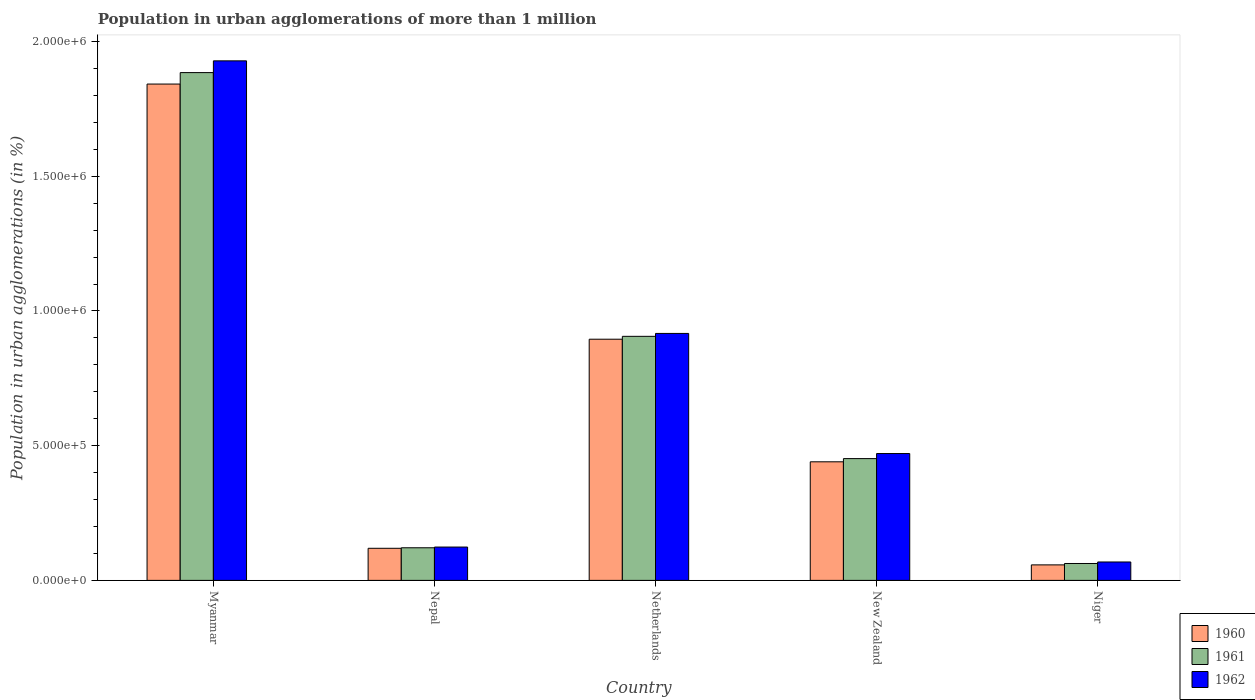How many different coloured bars are there?
Provide a short and direct response. 3. How many groups of bars are there?
Your response must be concise. 5. Are the number of bars on each tick of the X-axis equal?
Offer a terse response. Yes. How many bars are there on the 5th tick from the left?
Ensure brevity in your answer.  3. What is the label of the 1st group of bars from the left?
Provide a succinct answer. Myanmar. In how many cases, is the number of bars for a given country not equal to the number of legend labels?
Provide a short and direct response. 0. What is the population in urban agglomerations in 1960 in Niger?
Give a very brief answer. 5.75e+04. Across all countries, what is the maximum population in urban agglomerations in 1962?
Provide a succinct answer. 1.93e+06. Across all countries, what is the minimum population in urban agglomerations in 1962?
Ensure brevity in your answer.  6.83e+04. In which country was the population in urban agglomerations in 1960 maximum?
Make the answer very short. Myanmar. In which country was the population in urban agglomerations in 1960 minimum?
Offer a terse response. Niger. What is the total population in urban agglomerations in 1962 in the graph?
Offer a terse response. 3.51e+06. What is the difference between the population in urban agglomerations in 1961 in Netherlands and that in New Zealand?
Give a very brief answer. 4.54e+05. What is the difference between the population in urban agglomerations in 1961 in Myanmar and the population in urban agglomerations in 1962 in Niger?
Offer a terse response. 1.82e+06. What is the average population in urban agglomerations in 1960 per country?
Your response must be concise. 6.71e+05. What is the difference between the population in urban agglomerations of/in 1962 and population in urban agglomerations of/in 1960 in Nepal?
Provide a succinct answer. 4568. In how many countries, is the population in urban agglomerations in 1961 greater than 1900000 %?
Provide a succinct answer. 0. What is the ratio of the population in urban agglomerations in 1960 in Myanmar to that in Netherlands?
Make the answer very short. 2.06. Is the population in urban agglomerations in 1960 in Myanmar less than that in Netherlands?
Your answer should be compact. No. What is the difference between the highest and the second highest population in urban agglomerations in 1962?
Offer a very short reply. -1.01e+06. What is the difference between the highest and the lowest population in urban agglomerations in 1960?
Give a very brief answer. 1.78e+06. What does the 3rd bar from the left in Netherlands represents?
Offer a very short reply. 1962. What does the 1st bar from the right in Niger represents?
Make the answer very short. 1962. How many bars are there?
Provide a short and direct response. 15. Are all the bars in the graph horizontal?
Keep it short and to the point. No. How many countries are there in the graph?
Ensure brevity in your answer.  5. What is the difference between two consecutive major ticks on the Y-axis?
Give a very brief answer. 5.00e+05. Are the values on the major ticks of Y-axis written in scientific E-notation?
Ensure brevity in your answer.  Yes. Does the graph contain any zero values?
Keep it short and to the point. No. Does the graph contain grids?
Give a very brief answer. No. How are the legend labels stacked?
Your answer should be very brief. Vertical. What is the title of the graph?
Provide a short and direct response. Population in urban agglomerations of more than 1 million. Does "1969" appear as one of the legend labels in the graph?
Offer a very short reply. No. What is the label or title of the X-axis?
Give a very brief answer. Country. What is the label or title of the Y-axis?
Offer a terse response. Population in urban agglomerations (in %). What is the Population in urban agglomerations (in %) of 1960 in Myanmar?
Your response must be concise. 1.84e+06. What is the Population in urban agglomerations (in %) of 1961 in Myanmar?
Provide a succinct answer. 1.88e+06. What is the Population in urban agglomerations (in %) of 1962 in Myanmar?
Make the answer very short. 1.93e+06. What is the Population in urban agglomerations (in %) in 1960 in Nepal?
Your answer should be compact. 1.19e+05. What is the Population in urban agglomerations (in %) in 1961 in Nepal?
Keep it short and to the point. 1.21e+05. What is the Population in urban agglomerations (in %) in 1962 in Nepal?
Offer a very short reply. 1.24e+05. What is the Population in urban agglomerations (in %) of 1960 in Netherlands?
Ensure brevity in your answer.  8.95e+05. What is the Population in urban agglomerations (in %) of 1961 in Netherlands?
Your answer should be very brief. 9.06e+05. What is the Population in urban agglomerations (in %) of 1962 in Netherlands?
Ensure brevity in your answer.  9.17e+05. What is the Population in urban agglomerations (in %) in 1960 in New Zealand?
Your response must be concise. 4.40e+05. What is the Population in urban agglomerations (in %) of 1961 in New Zealand?
Your answer should be very brief. 4.52e+05. What is the Population in urban agglomerations (in %) in 1962 in New Zealand?
Keep it short and to the point. 4.71e+05. What is the Population in urban agglomerations (in %) of 1960 in Niger?
Your answer should be compact. 5.75e+04. What is the Population in urban agglomerations (in %) of 1961 in Niger?
Your answer should be compact. 6.27e+04. What is the Population in urban agglomerations (in %) in 1962 in Niger?
Keep it short and to the point. 6.83e+04. Across all countries, what is the maximum Population in urban agglomerations (in %) of 1960?
Your answer should be very brief. 1.84e+06. Across all countries, what is the maximum Population in urban agglomerations (in %) in 1961?
Make the answer very short. 1.88e+06. Across all countries, what is the maximum Population in urban agglomerations (in %) in 1962?
Make the answer very short. 1.93e+06. Across all countries, what is the minimum Population in urban agglomerations (in %) of 1960?
Your answer should be compact. 5.75e+04. Across all countries, what is the minimum Population in urban agglomerations (in %) of 1961?
Your answer should be very brief. 6.27e+04. Across all countries, what is the minimum Population in urban agglomerations (in %) in 1962?
Offer a very short reply. 6.83e+04. What is the total Population in urban agglomerations (in %) of 1960 in the graph?
Offer a terse response. 3.35e+06. What is the total Population in urban agglomerations (in %) in 1961 in the graph?
Ensure brevity in your answer.  3.43e+06. What is the total Population in urban agglomerations (in %) of 1962 in the graph?
Your answer should be compact. 3.51e+06. What is the difference between the Population in urban agglomerations (in %) of 1960 in Myanmar and that in Nepal?
Keep it short and to the point. 1.72e+06. What is the difference between the Population in urban agglomerations (in %) of 1961 in Myanmar and that in Nepal?
Ensure brevity in your answer.  1.76e+06. What is the difference between the Population in urban agglomerations (in %) in 1962 in Myanmar and that in Nepal?
Ensure brevity in your answer.  1.80e+06. What is the difference between the Population in urban agglomerations (in %) in 1960 in Myanmar and that in Netherlands?
Provide a succinct answer. 9.47e+05. What is the difference between the Population in urban agglomerations (in %) in 1961 in Myanmar and that in Netherlands?
Keep it short and to the point. 9.79e+05. What is the difference between the Population in urban agglomerations (in %) of 1962 in Myanmar and that in Netherlands?
Ensure brevity in your answer.  1.01e+06. What is the difference between the Population in urban agglomerations (in %) of 1960 in Myanmar and that in New Zealand?
Provide a short and direct response. 1.40e+06. What is the difference between the Population in urban agglomerations (in %) of 1961 in Myanmar and that in New Zealand?
Offer a terse response. 1.43e+06. What is the difference between the Population in urban agglomerations (in %) in 1962 in Myanmar and that in New Zealand?
Offer a very short reply. 1.46e+06. What is the difference between the Population in urban agglomerations (in %) in 1960 in Myanmar and that in Niger?
Provide a succinct answer. 1.78e+06. What is the difference between the Population in urban agglomerations (in %) of 1961 in Myanmar and that in Niger?
Make the answer very short. 1.82e+06. What is the difference between the Population in urban agglomerations (in %) of 1962 in Myanmar and that in Niger?
Your response must be concise. 1.86e+06. What is the difference between the Population in urban agglomerations (in %) of 1960 in Nepal and that in Netherlands?
Make the answer very short. -7.76e+05. What is the difference between the Population in urban agglomerations (in %) of 1961 in Nepal and that in Netherlands?
Your response must be concise. -7.85e+05. What is the difference between the Population in urban agglomerations (in %) in 1962 in Nepal and that in Netherlands?
Keep it short and to the point. -7.93e+05. What is the difference between the Population in urban agglomerations (in %) of 1960 in Nepal and that in New Zealand?
Keep it short and to the point. -3.21e+05. What is the difference between the Population in urban agglomerations (in %) in 1961 in Nepal and that in New Zealand?
Offer a very short reply. -3.31e+05. What is the difference between the Population in urban agglomerations (in %) of 1962 in Nepal and that in New Zealand?
Your answer should be compact. -3.47e+05. What is the difference between the Population in urban agglomerations (in %) of 1960 in Nepal and that in Niger?
Your response must be concise. 6.16e+04. What is the difference between the Population in urban agglomerations (in %) of 1961 in Nepal and that in Niger?
Provide a short and direct response. 5.84e+04. What is the difference between the Population in urban agglomerations (in %) of 1962 in Nepal and that in Niger?
Offer a very short reply. 5.54e+04. What is the difference between the Population in urban agglomerations (in %) of 1960 in Netherlands and that in New Zealand?
Your response must be concise. 4.55e+05. What is the difference between the Population in urban agglomerations (in %) in 1961 in Netherlands and that in New Zealand?
Keep it short and to the point. 4.54e+05. What is the difference between the Population in urban agglomerations (in %) of 1962 in Netherlands and that in New Zealand?
Your answer should be very brief. 4.46e+05. What is the difference between the Population in urban agglomerations (in %) in 1960 in Netherlands and that in Niger?
Provide a succinct answer. 8.38e+05. What is the difference between the Population in urban agglomerations (in %) in 1961 in Netherlands and that in Niger?
Offer a terse response. 8.43e+05. What is the difference between the Population in urban agglomerations (in %) in 1962 in Netherlands and that in Niger?
Provide a short and direct response. 8.48e+05. What is the difference between the Population in urban agglomerations (in %) of 1960 in New Zealand and that in Niger?
Provide a succinct answer. 3.83e+05. What is the difference between the Population in urban agglomerations (in %) in 1961 in New Zealand and that in Niger?
Your answer should be compact. 3.89e+05. What is the difference between the Population in urban agglomerations (in %) in 1962 in New Zealand and that in Niger?
Your answer should be very brief. 4.03e+05. What is the difference between the Population in urban agglomerations (in %) of 1960 in Myanmar and the Population in urban agglomerations (in %) of 1961 in Nepal?
Offer a very short reply. 1.72e+06. What is the difference between the Population in urban agglomerations (in %) of 1960 in Myanmar and the Population in urban agglomerations (in %) of 1962 in Nepal?
Make the answer very short. 1.72e+06. What is the difference between the Population in urban agglomerations (in %) of 1961 in Myanmar and the Population in urban agglomerations (in %) of 1962 in Nepal?
Ensure brevity in your answer.  1.76e+06. What is the difference between the Population in urban agglomerations (in %) of 1960 in Myanmar and the Population in urban agglomerations (in %) of 1961 in Netherlands?
Your answer should be compact. 9.36e+05. What is the difference between the Population in urban agglomerations (in %) of 1960 in Myanmar and the Population in urban agglomerations (in %) of 1962 in Netherlands?
Provide a succinct answer. 9.26e+05. What is the difference between the Population in urban agglomerations (in %) in 1961 in Myanmar and the Population in urban agglomerations (in %) in 1962 in Netherlands?
Give a very brief answer. 9.68e+05. What is the difference between the Population in urban agglomerations (in %) in 1960 in Myanmar and the Population in urban agglomerations (in %) in 1961 in New Zealand?
Ensure brevity in your answer.  1.39e+06. What is the difference between the Population in urban agglomerations (in %) in 1960 in Myanmar and the Population in urban agglomerations (in %) in 1962 in New Zealand?
Give a very brief answer. 1.37e+06. What is the difference between the Population in urban agglomerations (in %) of 1961 in Myanmar and the Population in urban agglomerations (in %) of 1962 in New Zealand?
Your answer should be compact. 1.41e+06. What is the difference between the Population in urban agglomerations (in %) in 1960 in Myanmar and the Population in urban agglomerations (in %) in 1961 in Niger?
Give a very brief answer. 1.78e+06. What is the difference between the Population in urban agglomerations (in %) in 1960 in Myanmar and the Population in urban agglomerations (in %) in 1962 in Niger?
Give a very brief answer. 1.77e+06. What is the difference between the Population in urban agglomerations (in %) in 1961 in Myanmar and the Population in urban agglomerations (in %) in 1962 in Niger?
Keep it short and to the point. 1.82e+06. What is the difference between the Population in urban agglomerations (in %) in 1960 in Nepal and the Population in urban agglomerations (in %) in 1961 in Netherlands?
Make the answer very short. -7.87e+05. What is the difference between the Population in urban agglomerations (in %) of 1960 in Nepal and the Population in urban agglomerations (in %) of 1962 in Netherlands?
Your answer should be very brief. -7.98e+05. What is the difference between the Population in urban agglomerations (in %) of 1961 in Nepal and the Population in urban agglomerations (in %) of 1962 in Netherlands?
Offer a very short reply. -7.96e+05. What is the difference between the Population in urban agglomerations (in %) in 1960 in Nepal and the Population in urban agglomerations (in %) in 1961 in New Zealand?
Your answer should be compact. -3.33e+05. What is the difference between the Population in urban agglomerations (in %) of 1960 in Nepal and the Population in urban agglomerations (in %) of 1962 in New Zealand?
Offer a very short reply. -3.52e+05. What is the difference between the Population in urban agglomerations (in %) of 1961 in Nepal and the Population in urban agglomerations (in %) of 1962 in New Zealand?
Offer a terse response. -3.50e+05. What is the difference between the Population in urban agglomerations (in %) in 1960 in Nepal and the Population in urban agglomerations (in %) in 1961 in Niger?
Keep it short and to the point. 5.65e+04. What is the difference between the Population in urban agglomerations (in %) in 1960 in Nepal and the Population in urban agglomerations (in %) in 1962 in Niger?
Your answer should be compact. 5.08e+04. What is the difference between the Population in urban agglomerations (in %) in 1961 in Nepal and the Population in urban agglomerations (in %) in 1962 in Niger?
Your answer should be compact. 5.28e+04. What is the difference between the Population in urban agglomerations (in %) in 1960 in Netherlands and the Population in urban agglomerations (in %) in 1961 in New Zealand?
Your answer should be compact. 4.43e+05. What is the difference between the Population in urban agglomerations (in %) of 1960 in Netherlands and the Population in urban agglomerations (in %) of 1962 in New Zealand?
Keep it short and to the point. 4.24e+05. What is the difference between the Population in urban agglomerations (in %) in 1961 in Netherlands and the Population in urban agglomerations (in %) in 1962 in New Zealand?
Ensure brevity in your answer.  4.35e+05. What is the difference between the Population in urban agglomerations (in %) of 1960 in Netherlands and the Population in urban agglomerations (in %) of 1961 in Niger?
Your answer should be compact. 8.33e+05. What is the difference between the Population in urban agglomerations (in %) of 1960 in Netherlands and the Population in urban agglomerations (in %) of 1962 in Niger?
Your response must be concise. 8.27e+05. What is the difference between the Population in urban agglomerations (in %) of 1961 in Netherlands and the Population in urban agglomerations (in %) of 1962 in Niger?
Provide a succinct answer. 8.38e+05. What is the difference between the Population in urban agglomerations (in %) in 1960 in New Zealand and the Population in urban agglomerations (in %) in 1961 in Niger?
Your response must be concise. 3.77e+05. What is the difference between the Population in urban agglomerations (in %) of 1960 in New Zealand and the Population in urban agglomerations (in %) of 1962 in Niger?
Your answer should be very brief. 3.72e+05. What is the difference between the Population in urban agglomerations (in %) in 1961 in New Zealand and the Population in urban agglomerations (in %) in 1962 in Niger?
Make the answer very short. 3.84e+05. What is the average Population in urban agglomerations (in %) of 1960 per country?
Offer a terse response. 6.71e+05. What is the average Population in urban agglomerations (in %) of 1961 per country?
Keep it short and to the point. 6.85e+05. What is the average Population in urban agglomerations (in %) in 1962 per country?
Ensure brevity in your answer.  7.02e+05. What is the difference between the Population in urban agglomerations (in %) in 1960 and Population in urban agglomerations (in %) in 1961 in Myanmar?
Your answer should be very brief. -4.25e+04. What is the difference between the Population in urban agglomerations (in %) of 1960 and Population in urban agglomerations (in %) of 1962 in Myanmar?
Offer a very short reply. -8.61e+04. What is the difference between the Population in urban agglomerations (in %) in 1961 and Population in urban agglomerations (in %) in 1962 in Myanmar?
Ensure brevity in your answer.  -4.36e+04. What is the difference between the Population in urban agglomerations (in %) in 1960 and Population in urban agglomerations (in %) in 1961 in Nepal?
Provide a succinct answer. -1907. What is the difference between the Population in urban agglomerations (in %) in 1960 and Population in urban agglomerations (in %) in 1962 in Nepal?
Your answer should be very brief. -4568. What is the difference between the Population in urban agglomerations (in %) of 1961 and Population in urban agglomerations (in %) of 1962 in Nepal?
Offer a very short reply. -2661. What is the difference between the Population in urban agglomerations (in %) in 1960 and Population in urban agglomerations (in %) in 1961 in Netherlands?
Offer a very short reply. -1.07e+04. What is the difference between the Population in urban agglomerations (in %) in 1960 and Population in urban agglomerations (in %) in 1962 in Netherlands?
Your answer should be compact. -2.15e+04. What is the difference between the Population in urban agglomerations (in %) of 1961 and Population in urban agglomerations (in %) of 1962 in Netherlands?
Your answer should be compact. -1.08e+04. What is the difference between the Population in urban agglomerations (in %) of 1960 and Population in urban agglomerations (in %) of 1961 in New Zealand?
Keep it short and to the point. -1.19e+04. What is the difference between the Population in urban agglomerations (in %) of 1960 and Population in urban agglomerations (in %) of 1962 in New Zealand?
Provide a succinct answer. -3.07e+04. What is the difference between the Population in urban agglomerations (in %) in 1961 and Population in urban agglomerations (in %) in 1962 in New Zealand?
Provide a succinct answer. -1.88e+04. What is the difference between the Population in urban agglomerations (in %) in 1960 and Population in urban agglomerations (in %) in 1961 in Niger?
Offer a terse response. -5156. What is the difference between the Population in urban agglomerations (in %) of 1960 and Population in urban agglomerations (in %) of 1962 in Niger?
Provide a succinct answer. -1.08e+04. What is the difference between the Population in urban agglomerations (in %) in 1961 and Population in urban agglomerations (in %) in 1962 in Niger?
Your answer should be very brief. -5625. What is the ratio of the Population in urban agglomerations (in %) of 1960 in Myanmar to that in Nepal?
Your answer should be compact. 15.46. What is the ratio of the Population in urban agglomerations (in %) of 1961 in Myanmar to that in Nepal?
Offer a very short reply. 15.57. What is the ratio of the Population in urban agglomerations (in %) in 1962 in Myanmar to that in Nepal?
Make the answer very short. 15.58. What is the ratio of the Population in urban agglomerations (in %) of 1960 in Myanmar to that in Netherlands?
Keep it short and to the point. 2.06. What is the ratio of the Population in urban agglomerations (in %) in 1961 in Myanmar to that in Netherlands?
Your answer should be compact. 2.08. What is the ratio of the Population in urban agglomerations (in %) in 1962 in Myanmar to that in Netherlands?
Offer a very short reply. 2.1. What is the ratio of the Population in urban agglomerations (in %) in 1960 in Myanmar to that in New Zealand?
Provide a succinct answer. 4.19. What is the ratio of the Population in urban agglomerations (in %) of 1961 in Myanmar to that in New Zealand?
Provide a succinct answer. 4.17. What is the ratio of the Population in urban agglomerations (in %) in 1962 in Myanmar to that in New Zealand?
Ensure brevity in your answer.  4.1. What is the ratio of the Population in urban agglomerations (in %) of 1960 in Myanmar to that in Niger?
Give a very brief answer. 32.01. What is the ratio of the Population in urban agglomerations (in %) in 1961 in Myanmar to that in Niger?
Offer a terse response. 30.06. What is the ratio of the Population in urban agglomerations (in %) in 1962 in Myanmar to that in Niger?
Your answer should be compact. 28.22. What is the ratio of the Population in urban agglomerations (in %) of 1960 in Nepal to that in Netherlands?
Offer a very short reply. 0.13. What is the ratio of the Population in urban agglomerations (in %) of 1961 in Nepal to that in Netherlands?
Provide a succinct answer. 0.13. What is the ratio of the Population in urban agglomerations (in %) in 1962 in Nepal to that in Netherlands?
Give a very brief answer. 0.14. What is the ratio of the Population in urban agglomerations (in %) in 1960 in Nepal to that in New Zealand?
Provide a succinct answer. 0.27. What is the ratio of the Population in urban agglomerations (in %) of 1961 in Nepal to that in New Zealand?
Your response must be concise. 0.27. What is the ratio of the Population in urban agglomerations (in %) of 1962 in Nepal to that in New Zealand?
Give a very brief answer. 0.26. What is the ratio of the Population in urban agglomerations (in %) of 1960 in Nepal to that in Niger?
Give a very brief answer. 2.07. What is the ratio of the Population in urban agglomerations (in %) of 1961 in Nepal to that in Niger?
Offer a terse response. 1.93. What is the ratio of the Population in urban agglomerations (in %) in 1962 in Nepal to that in Niger?
Offer a very short reply. 1.81. What is the ratio of the Population in urban agglomerations (in %) of 1960 in Netherlands to that in New Zealand?
Your response must be concise. 2.03. What is the ratio of the Population in urban agglomerations (in %) of 1961 in Netherlands to that in New Zealand?
Your answer should be compact. 2. What is the ratio of the Population in urban agglomerations (in %) of 1962 in Netherlands to that in New Zealand?
Your answer should be very brief. 1.95. What is the ratio of the Population in urban agglomerations (in %) in 1960 in Netherlands to that in Niger?
Provide a succinct answer. 15.56. What is the ratio of the Population in urban agglomerations (in %) in 1961 in Netherlands to that in Niger?
Your answer should be very brief. 14.45. What is the ratio of the Population in urban agglomerations (in %) in 1962 in Netherlands to that in Niger?
Provide a short and direct response. 13.42. What is the ratio of the Population in urban agglomerations (in %) in 1960 in New Zealand to that in Niger?
Your answer should be compact. 7.65. What is the ratio of the Population in urban agglomerations (in %) of 1961 in New Zealand to that in Niger?
Give a very brief answer. 7.21. What is the ratio of the Population in urban agglomerations (in %) of 1962 in New Zealand to that in Niger?
Your answer should be very brief. 6.89. What is the difference between the highest and the second highest Population in urban agglomerations (in %) of 1960?
Give a very brief answer. 9.47e+05. What is the difference between the highest and the second highest Population in urban agglomerations (in %) in 1961?
Make the answer very short. 9.79e+05. What is the difference between the highest and the second highest Population in urban agglomerations (in %) of 1962?
Your response must be concise. 1.01e+06. What is the difference between the highest and the lowest Population in urban agglomerations (in %) in 1960?
Your response must be concise. 1.78e+06. What is the difference between the highest and the lowest Population in urban agglomerations (in %) of 1961?
Your response must be concise. 1.82e+06. What is the difference between the highest and the lowest Population in urban agglomerations (in %) of 1962?
Provide a succinct answer. 1.86e+06. 